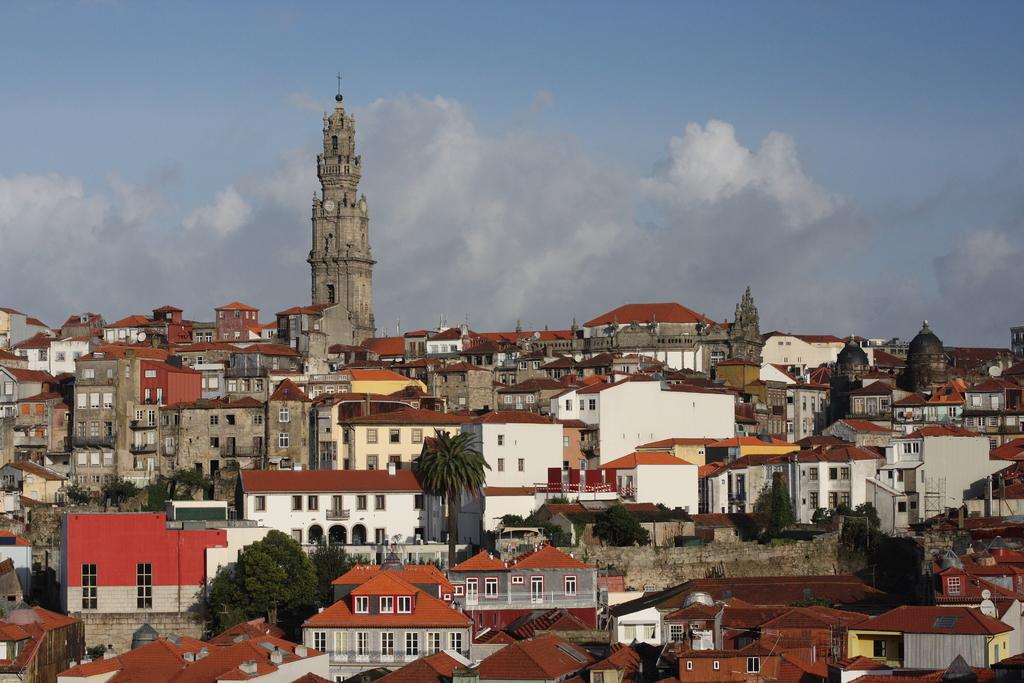What type of structures can be seen in the image? There are buildings in the image. What type of plant is present in the image? There is a tree in the image. What type of religious building can be seen in the background of the image? There is a church in the background of the image. What part of the natural environment is visible in the image? The sky is visible in the image. What type of pen is being used to write on the church in the image? There is no pen or writing present on the church in the image. How many bombs can be seen in the image? There are no bombs present in the image. 